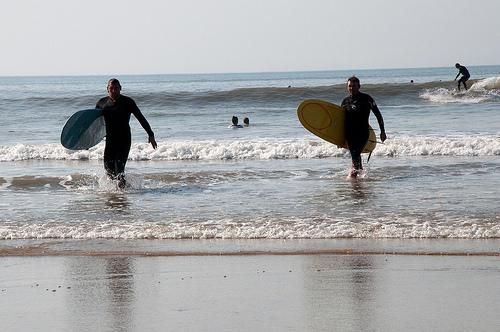Question: who is in photo?
Choices:
A. Surfers.
B. Grandparents.
C. The defence's lawyers.
D. The judge.
Answer with the letter. Answer: A Question: where are they?
Choices:
A. About 20 minutes away.
B. On the cruise ship.
C. Ocean.
D. At a rodeo.
Answer with the letter. Answer: C Question: who is holding yellow board?
Choices:
A. The construction worker.
B. The leader.
C. Man on right.
D. The teacher.
Answer with the letter. Answer: C 